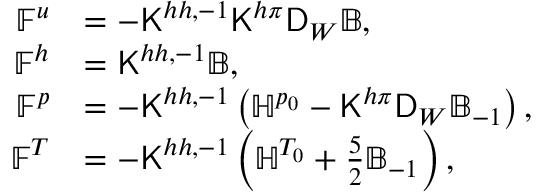Convert formula to latex. <formula><loc_0><loc_0><loc_500><loc_500>\begin{array} { r l } { \mathbb { F } ^ { u } } & { = - K ^ { h h , - 1 } K ^ { h \pi } D _ { W } \mathbb { B } , } \\ { \mathbb { F } ^ { h } } & { = K ^ { h h , - 1 } \mathbb { B } , } \\ { \mathbb { F } ^ { p } } & { = - K ^ { h h , - 1 } \left ( \mathbb { H } ^ { p _ { 0 } } - K ^ { h \pi } D _ { W } \mathbb { B } _ { - 1 } \right ) , } \\ { \mathbb { F } ^ { T } } & { = - K ^ { h h , - 1 } \left ( \mathbb { H } ^ { T _ { 0 } } + \frac { 5 } { 2 } \mathbb { B } _ { - 1 } \right ) , } \end{array}</formula> 